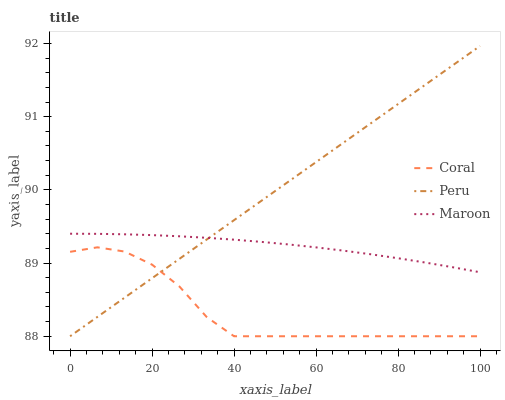Does Coral have the minimum area under the curve?
Answer yes or no. Yes. Does Peru have the maximum area under the curve?
Answer yes or no. Yes. Does Maroon have the minimum area under the curve?
Answer yes or no. No. Does Maroon have the maximum area under the curve?
Answer yes or no. No. Is Peru the smoothest?
Answer yes or no. Yes. Is Coral the roughest?
Answer yes or no. Yes. Is Maroon the smoothest?
Answer yes or no. No. Is Maroon the roughest?
Answer yes or no. No. Does Coral have the lowest value?
Answer yes or no. Yes. Does Maroon have the lowest value?
Answer yes or no. No. Does Peru have the highest value?
Answer yes or no. Yes. Does Maroon have the highest value?
Answer yes or no. No. Is Coral less than Maroon?
Answer yes or no. Yes. Is Maroon greater than Coral?
Answer yes or no. Yes. Does Maroon intersect Peru?
Answer yes or no. Yes. Is Maroon less than Peru?
Answer yes or no. No. Is Maroon greater than Peru?
Answer yes or no. No. Does Coral intersect Maroon?
Answer yes or no. No. 